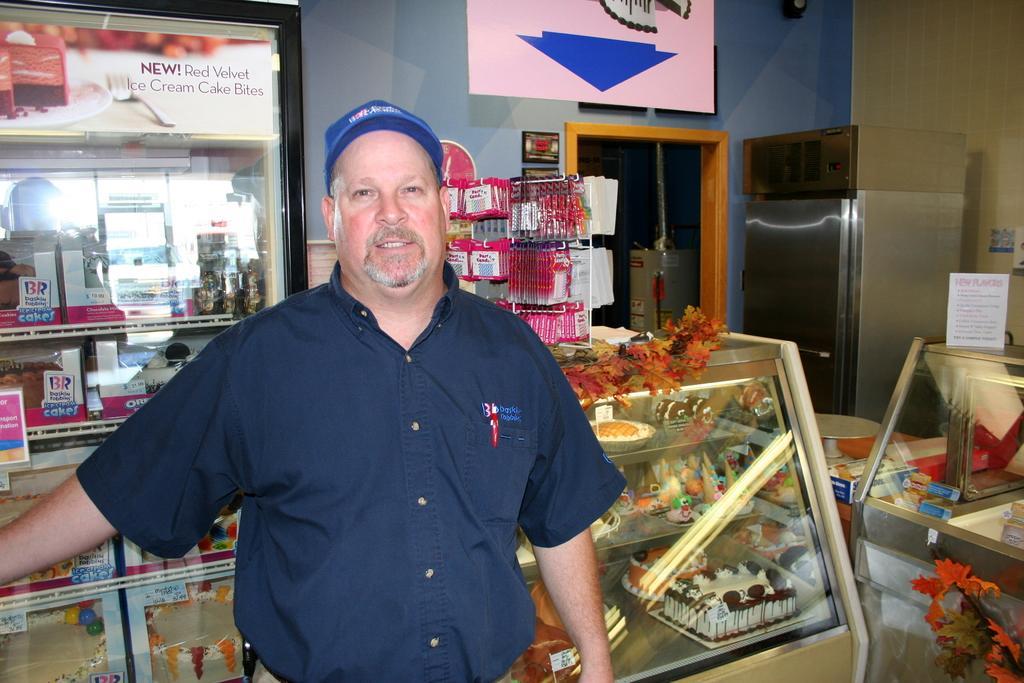Could you give a brief overview of what you see in this image? In the picture I can see a man is standing. In the background I can see cakes, refrigerators, wall and some other things. 